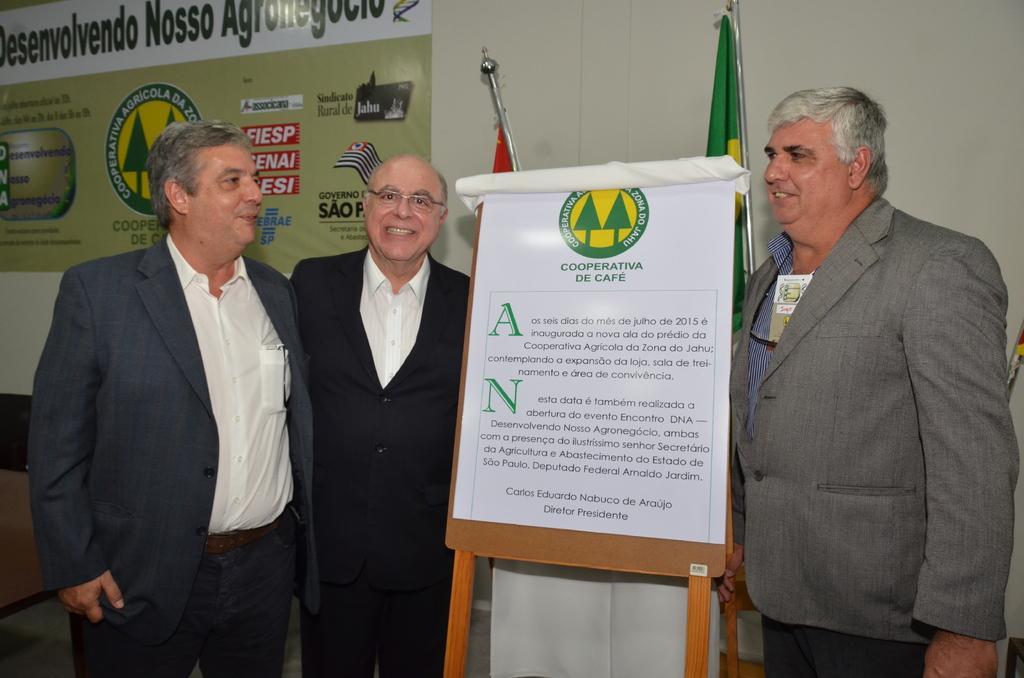Can you describe this image briefly? In the center of the image there is a board. Behind the board there are two flags. Beside the bord there are three people wearing a smile on their faces. Behind them there is a poster attached to the wall. On the left side of the image there is a table. 